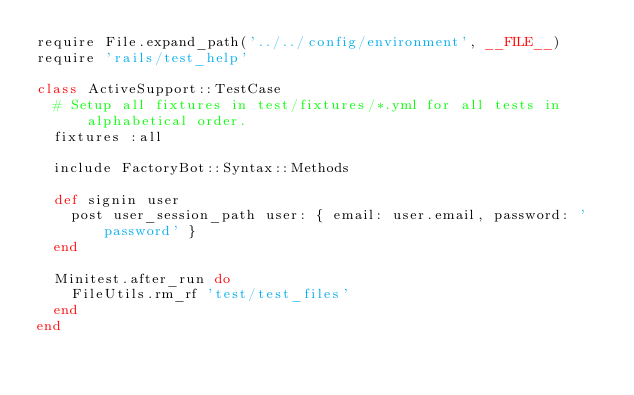Convert code to text. <code><loc_0><loc_0><loc_500><loc_500><_Ruby_>require File.expand_path('../../config/environment', __FILE__)
require 'rails/test_help'

class ActiveSupport::TestCase
  # Setup all fixtures in test/fixtures/*.yml for all tests in alphabetical order.
  fixtures :all

  include FactoryBot::Syntax::Methods

  def signin user
    post user_session_path user: { email: user.email, password: 'password' }
  end

  Minitest.after_run do
    FileUtils.rm_rf 'test/test_files'
  end
end
</code> 